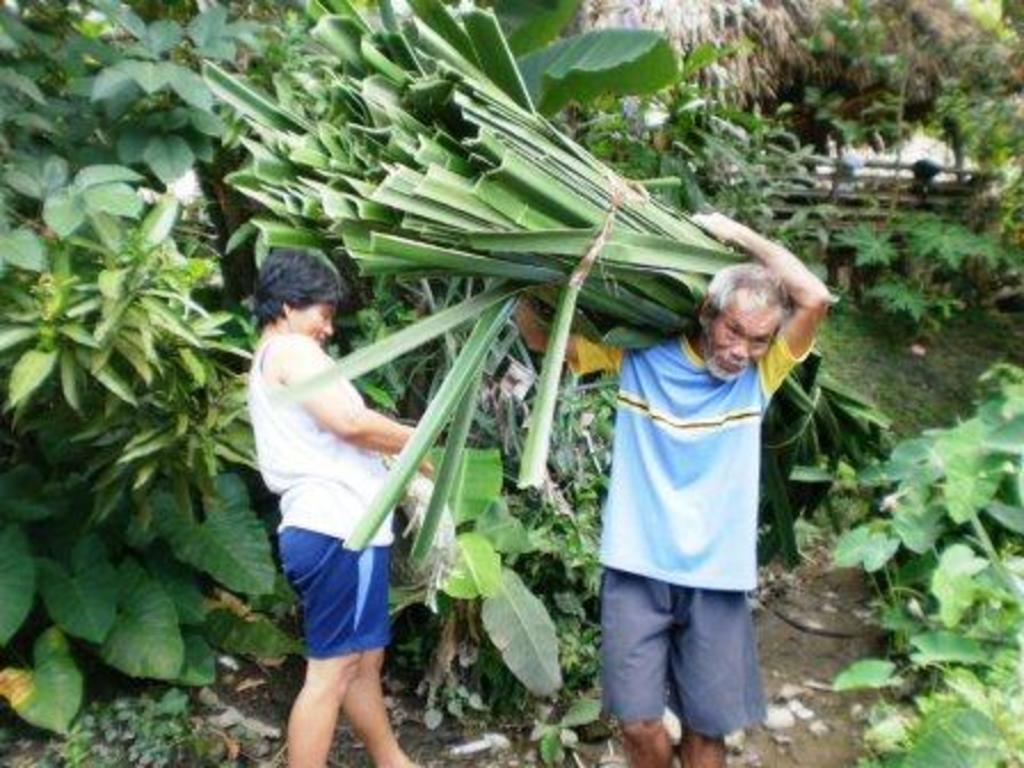How many people are in the image? There are two persons in the image. What can be seen in the background of the image? There are many trees and plants in the image. What is the man in the image doing? A man is carrying leaves of a plant on his shoulder. How many cows are visible in the image? There are no cows present in the image; it features two persons and many trees and plants. 